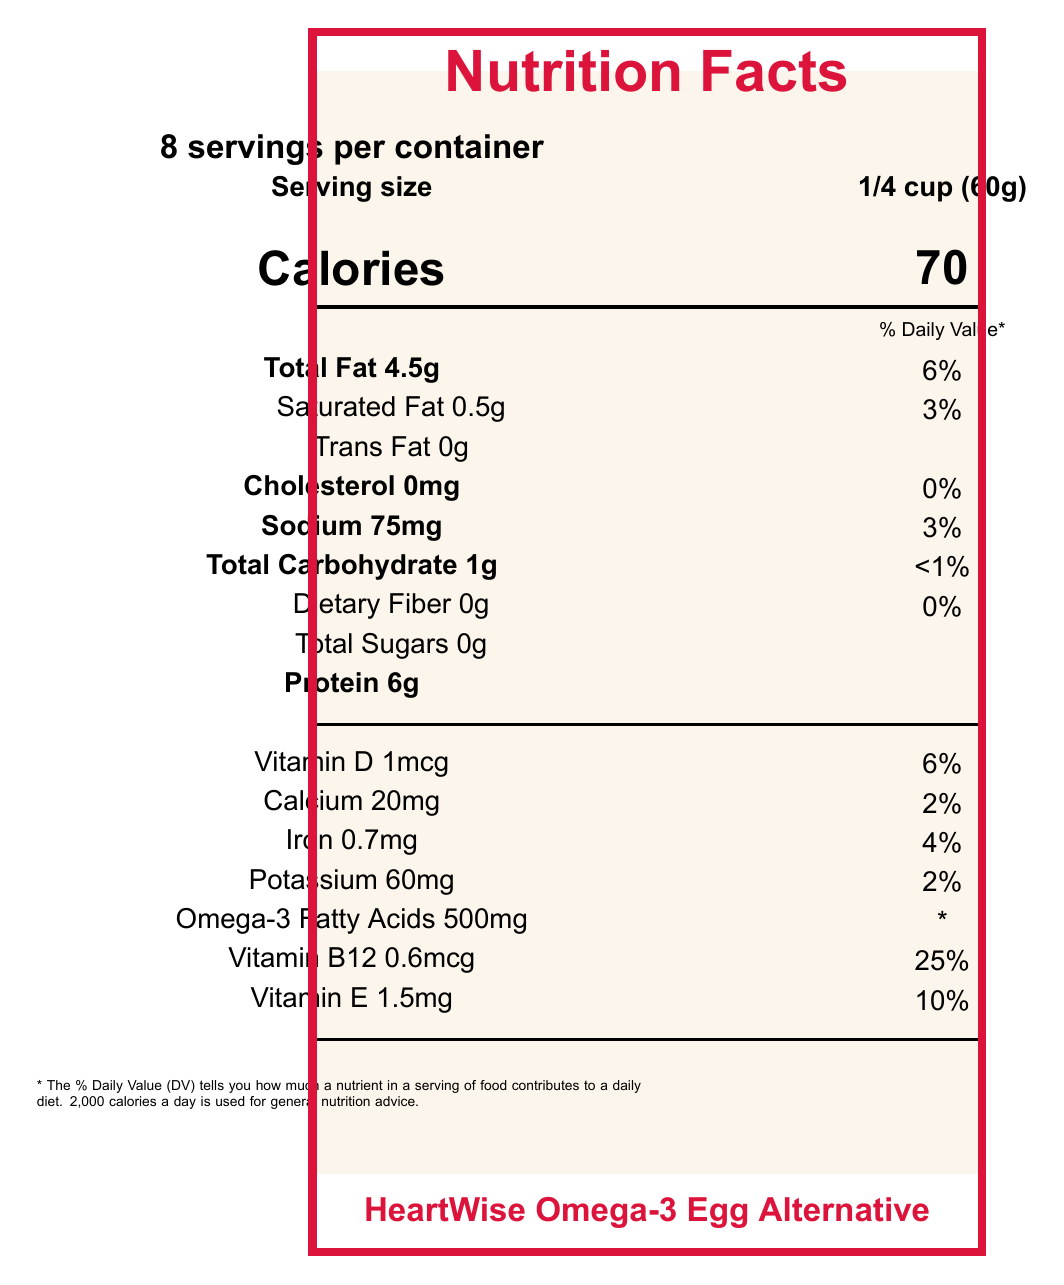what is the serving size for HeartWise Omega-3 Egg Alternative? The serving size is listed as 1/4 cup (60g) in the nutrition facts label.
Answer: 1/4 cup (60g) how many calories are in one serving? The number of calories per serving is stated as 70.
Answer: 70 how much protein is in one serving? The amount of protein per serving is listed as 6g.
Answer: 6g how much cholesterol does one serving contain? The label specifies that one serving contains 0mg of cholesterol.
Answer: 0mg what is the daily value percentage for saturated fat? The daily value percentage for saturated fat is indicated as 3%.
Answer: 3% how many servings per container? The document states there are 8 servings per container.
Answer: 8 what is the amount of total carbohydrates per serving? The total carbohydrate content per serving is 1g.
Answer: 1g what is the % daily value for vitamin D? The daily value percentage for vitamin D is provided as 6%.
Answer: 6% how does the omega-3 content in HeartWise compare to a regular egg? A. The same B. Less C. More HeartWise contains 500mg of omega-3 fatty acids per serving, whereas a regular egg contains about 30mg.
Answer: C how many milligrams of sodium are in one serving? A. 75mg B. 60mg C. 20mg The document indicates there are 75mg of sodium in one serving.
Answer: A how much vitamin B12 is in one serving? A. 0.6mcg B. 1mcg C. 0.7mg The nutrition facts show that there is 0.6mcg of vitamin B12 per serving.
Answer: A is HeartWise Omega-3 Egg Alternative cholesterol-free? The label specifies that it contains 0mg of cholesterol, making it cholesterol-free.
Answer: Yes does the product contain any allergens? The allergen information states that it contains no allergens but is produced in a facility that processes tree nuts and soy.
Answer: No describe the main idea of the document. The document provides comprehensive nutritional information about HeartWise Omega-3 Egg Alternative, including its benefits over regular eggs and its certifications.
Answer: The document is a nutrition facts label for HeartWise Omega-3 Egg Alternative, detailing the serving size, nutritional content, ingredients, allergen information, health claims, comparison to regular eggs, preparation, and storage instructions. what is the preparation instruction for the product? The preparation instructions in the document outline how to use the product in various recipes by specifying a serving size equivalent to one whole egg and suggesting possible recipes such as baking, scrambling, and making omelets.
Answer: Shake well before use. Use 1/4 cup (60g) to replace one whole egg in recipes. Suitable for baking, scrambling, and making omelets. how should HeartWise Omega-3 Egg Alternative be stored? The storage instruction section states that the product must be kept refrigerated and used within 7 days after opening.
Answer: Keep refrigerated. Use within 7 days after opening. what does the "Non-GMO Project Verified" logo indicate? The document contains the "Non-GMO Project Verified" logo, but it does not explain what it signifies.
Answer: Cannot be determined 